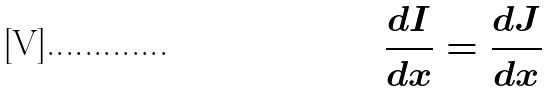Convert formula to latex. <formula><loc_0><loc_0><loc_500><loc_500>\frac { d I } { d x } = \frac { d J } { d x }</formula> 